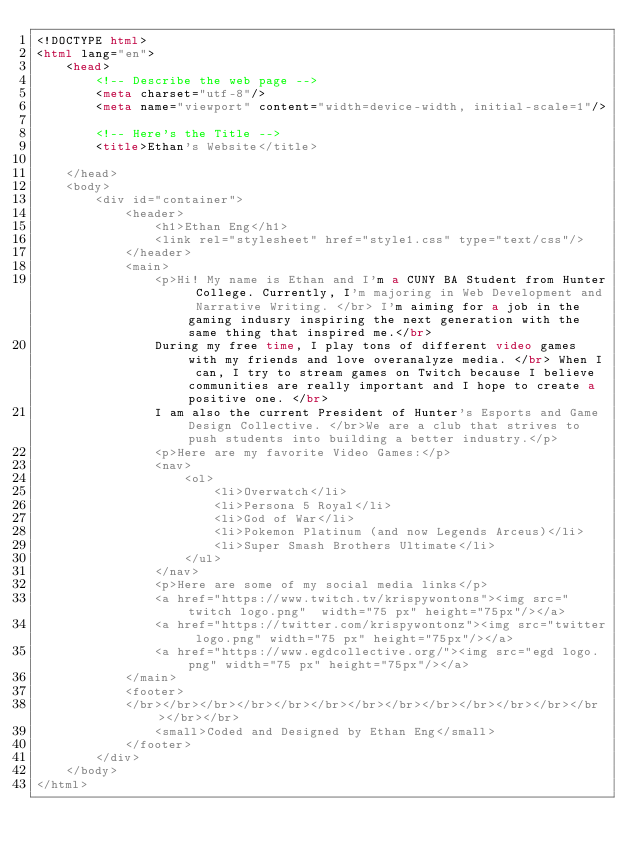Convert code to text. <code><loc_0><loc_0><loc_500><loc_500><_HTML_><!DOCTYPE html>
<html lang="en">
    <head>
        <!-- Describe the web page -->
        <meta charset="utf-8"/>
        <meta name="viewport" content="width=device-width, initial-scale=1"/>

        <!-- Here's the Title -->
        <title>Ethan's Website</title>

    </head>
    <body>
        <div id="container">
            <header>
                <h1>Ethan Eng</h1> 
                <link rel="stylesheet" href="style1.css" type="text/css"/>
            </header>
            <main>
                <p>Hi! My name is Ethan and I'm a CUNY BA Student from Hunter College. Currently, I'm majoring in Web Development and Narrative Writing. </br> I'm aiming for a job in the gaming indusry inspiring the next generation with the same thing that inspired me.</br>
                During my free time, I play tons of different video games with my friends and love overanalyze media. </br> When I can, I try to stream games on Twitch because I believe communities are really important and I hope to create a positive one. </br>
                I am also the current President of Hunter's Esports and Game Design Collective. </br>We are a club that strives to push students into building a better industry.</p>
                <p>Here are my favorite Video Games:</p>
                <nav>
                    <ol>
                        <li>Overwatch</li>
                        <li>Persona 5 Royal</li>
                        <li>God of War</li>
                        <li>Pokemon Platinum (and now Legends Arceus)</li>
                        <li>Super Smash Brothers Ultimate</li>
                    </ul>
                </nav>
                <p>Here are some of my social media links</p>
                <a href="https://www.twitch.tv/krispywontons"><img src="twitch logo.png"  width="75 px" height="75px"/></a>
                <a href="https://twitter.com/krispywontonz"><img src="twitter logo.png" width="75 px" height="75px"/></a>
                <a href="https://www.egdcollective.org/"><img src="egd logo.png" width="75 px" height="75px"/></a>
            </main>
            <footer>
            </br></br></br></br></br></br></br></br></br></br></br></br></br></br></br>
                <small>Coded and Designed by Ethan Eng</small>
            </footer>
        </div>
    </body>
</html></code> 